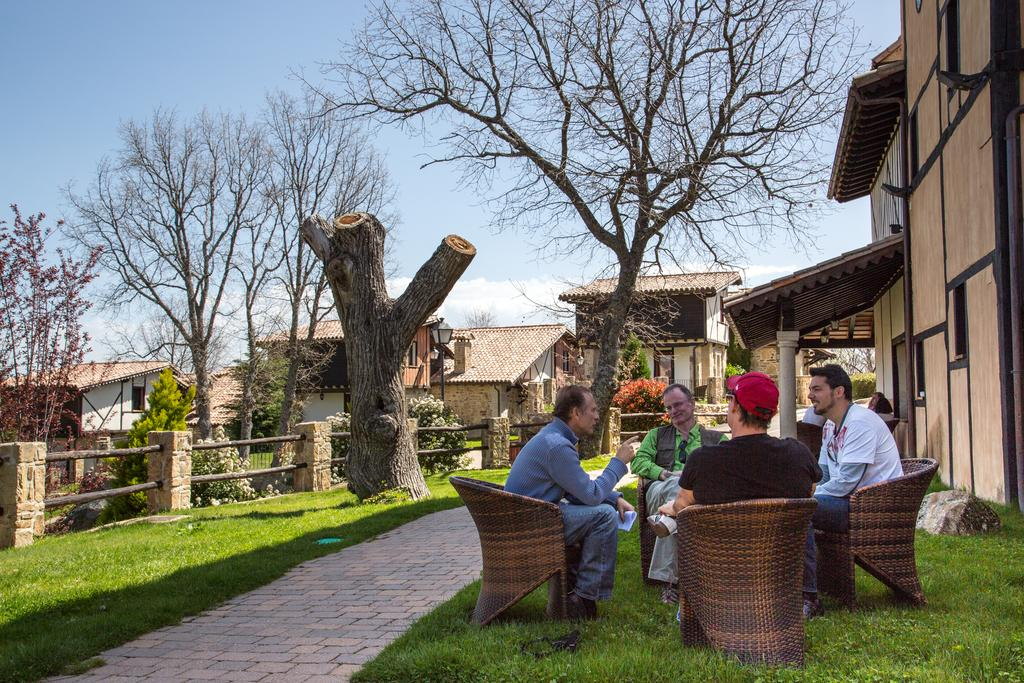What type of vegetation is present in the image? There is grass in the image. What are the people in the image doing? The people are sitting on chairs in the image. What type of structures can be seen in the image? There are houses in the image. What else can be seen in the image besides the grass and houses? There are trees in the image. What is visible in the background of the image? The sky is visible in the image. Can you tell me how many toes the grandmother has in the image? There is no grandmother present in the image, and therefore no toes to count. What type of ducks can be seen swimming in the grass in the image? There are no ducks present in the image; it features grass, houses, trees, and people sitting on chairs. 